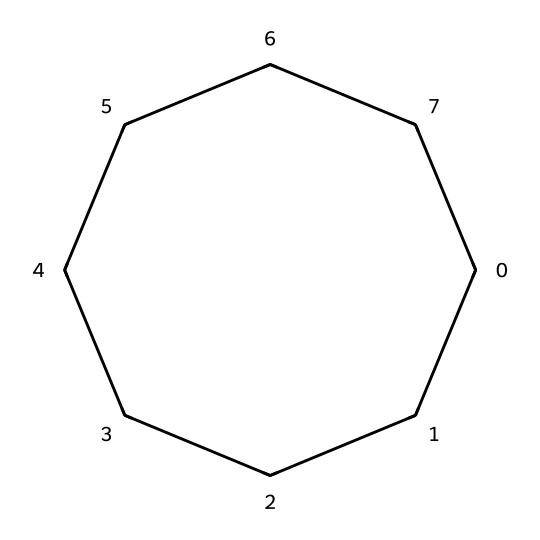How many carbon atoms are in cyclooctane? The SMILES representation shows "C1CCCCCCC1", which indicates a cyclic structure. Counting the 'C' symbols, we find there are 8 carbon atoms total.
Answer: 8 What is the name of the cyclic alkane represented? The structure corresponds to cyclooctane, which is named based on the presence of a ring (cyclo) and contains 8 carbon atoms (octane).
Answer: cyclooctane What is the degree of saturation of cyclooctane? Cyclooctane is a saturated hydrocarbon, meaning it contains only single bonds and has no double or triple bonds. Therefore, it has a degree of saturation equal to the number of carbon atoms, which is 8.
Answer: 8 How many hydrogen atoms are expected in cyclooctane? For cycloalkanes, the formula is CnH2n. Here, n is the number of carbon atoms (8), so it would be 2*8 = 16 hydrogen atoms in cyclooctane.
Answer: 16 What is the shape of the cyclooctane molecule? Cyclooctane adopts a non-planar conformation to minimize angle strain, resulting in a boat or chair shape; however, the overall geometry can be described as a circular arrangement due to the cyclo structure.
Answer: circular Is cyclooctane more stable than cyclopentane? Cyclooctane is larger and has fewer angle strain issues than cyclopentane, leading to greater stability due to less ring strain from bond angles deviating from the ideal tetrahedral geometry in smaller rings.
Answer: more stable What type of bonds are present in cyclooctane? The structure's SMILES representation shows only single bonds connecting the carbon atoms, confirming that cyclooctane consists solely of sigma bonds.
Answer: sigma bonds 